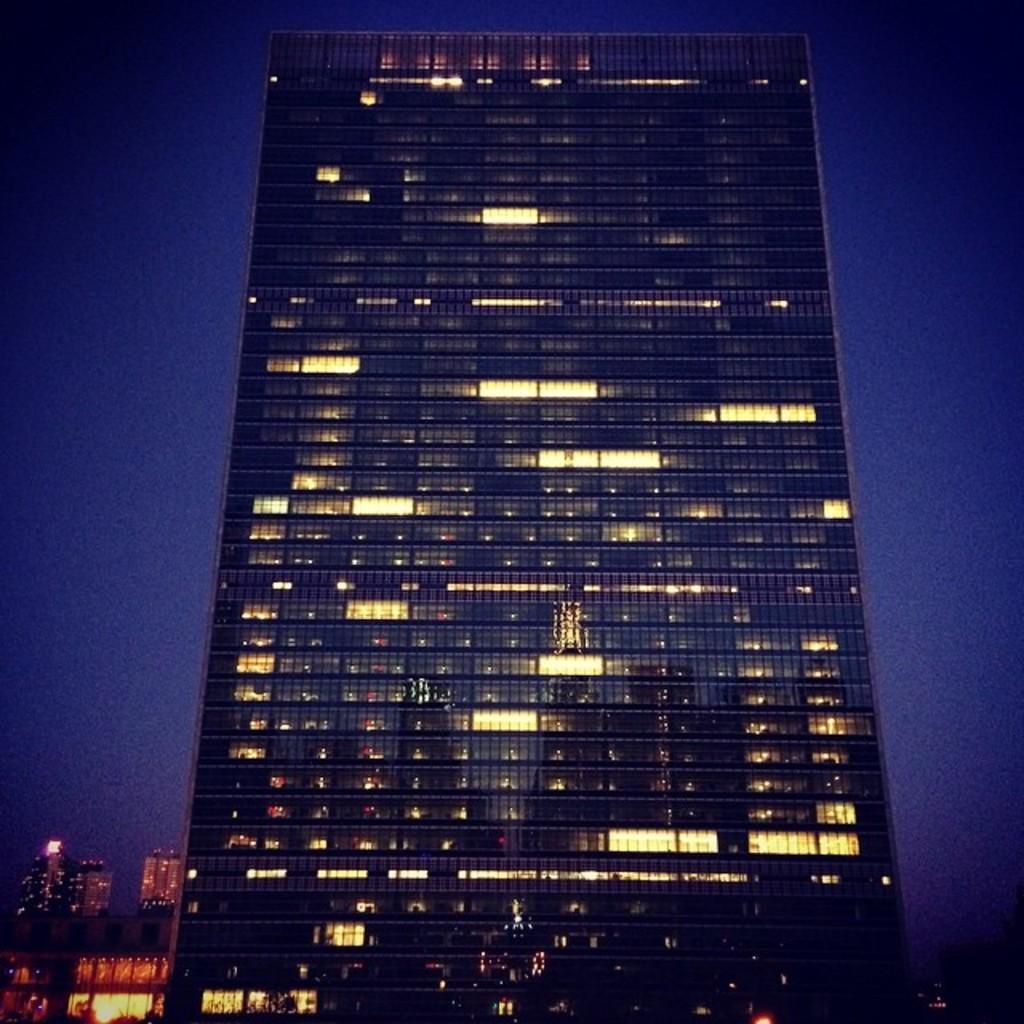Describe this image in one or two sentences. In this image there are buildings. In the background there is sky. 